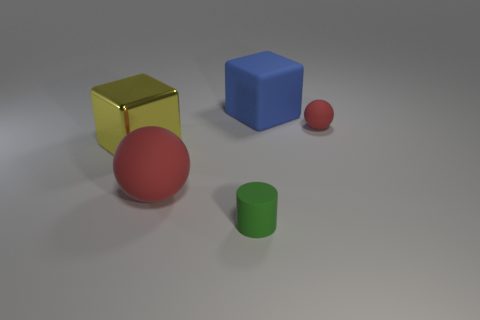Add 3 big red matte balls. How many objects exist? 8 Subtract all balls. How many objects are left? 3 Add 4 rubber cylinders. How many rubber cylinders are left? 5 Add 1 green matte things. How many green matte things exist? 2 Subtract 0 purple spheres. How many objects are left? 5 Subtract all tiny objects. Subtract all large purple things. How many objects are left? 3 